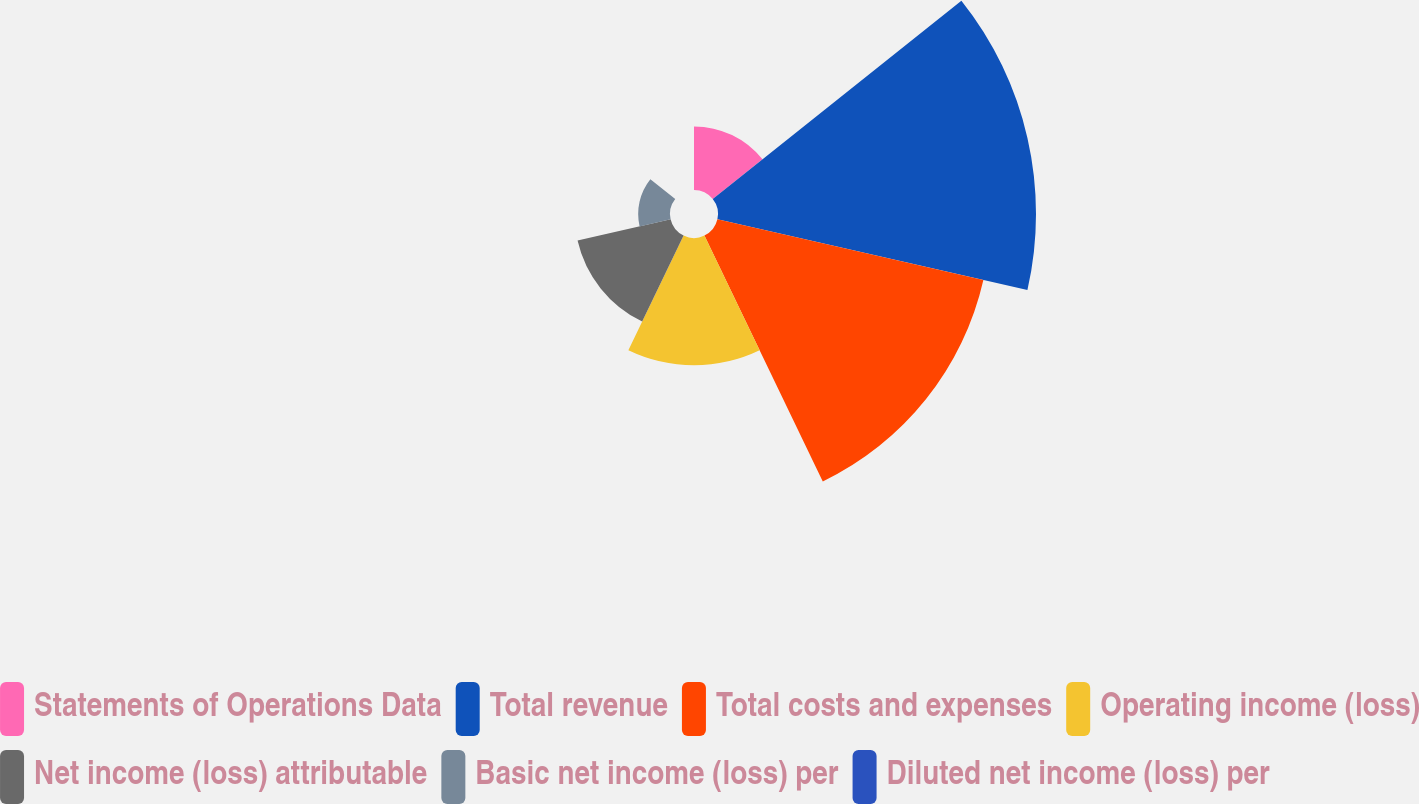Convert chart to OTSL. <chart><loc_0><loc_0><loc_500><loc_500><pie_chart><fcel>Statements of Operations Data<fcel>Total revenue<fcel>Total costs and expenses<fcel>Operating income (loss)<fcel>Net income (loss) attributable<fcel>Basic net income (loss) per<fcel>Diluted net income (loss) per<nl><fcel>7.0%<fcel>34.99%<fcel>30.02%<fcel>14.0%<fcel>10.5%<fcel>3.5%<fcel>0.0%<nl></chart> 